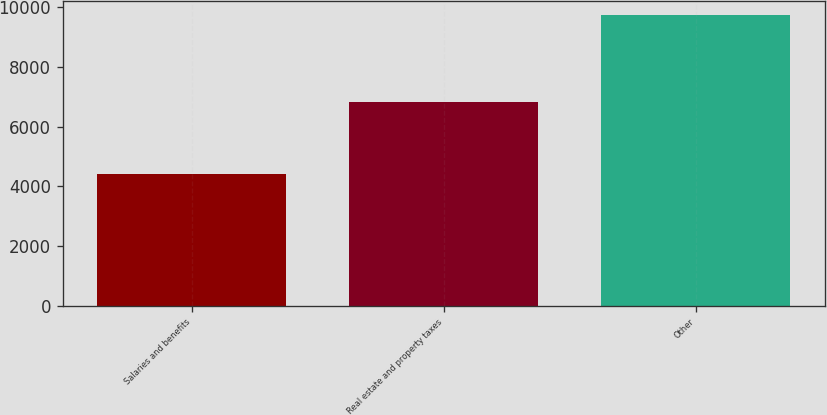Convert chart. <chart><loc_0><loc_0><loc_500><loc_500><bar_chart><fcel>Salaries and benefits<fcel>Real estate and property taxes<fcel>Other<nl><fcel>4401<fcel>6820<fcel>9743<nl></chart> 